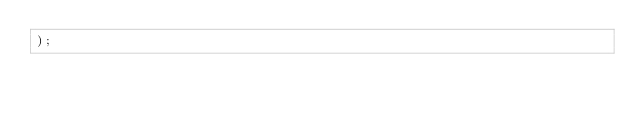<code> <loc_0><loc_0><loc_500><loc_500><_SQL_>);
</code> 